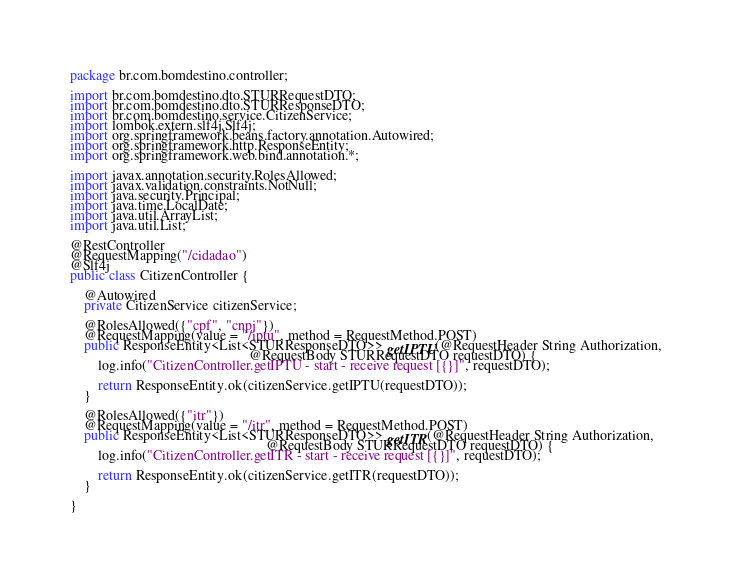Convert code to text. <code><loc_0><loc_0><loc_500><loc_500><_Java_>package br.com.bomdestino.controller;

import br.com.bomdestino.dto.STURRequestDTO;
import br.com.bomdestino.dto.STURResponseDTO;
import br.com.bomdestino.service.CitizenService;
import lombok.extern.slf4j.Slf4j;
import org.springframework.beans.factory.annotation.Autowired;
import org.springframework.http.ResponseEntity;
import org.springframework.web.bind.annotation.*;

import javax.annotation.security.RolesAllowed;
import javax.validation.constraints.NotNull;
import java.security.Principal;
import java.time.LocalDate;
import java.util.ArrayList;
import java.util.List;

@RestController
@RequestMapping("/cidadao")
@Slf4j
public class CitizenController {

    @Autowired
    private CitizenService citizenService;

    @RolesAllowed({"cpf", "cnpj"})
    @RequestMapping(value = "/iptu", method = RequestMethod.POST)
    public ResponseEntity<List<STURResponseDTO>> getIPTU(@RequestHeader String Authorization,
                                                   @RequestBody STURRequestDTO requestDTO) {
        log.info("CitizenController.getIPTU - start - receive request [{}]", requestDTO);

        return ResponseEntity.ok(citizenService.getIPTU(requestDTO));
    }

    @RolesAllowed({"itr"})
    @RequestMapping(value = "/itr", method = RequestMethod.POST)
    public ResponseEntity<List<STURResponseDTO>> getITR(@RequestHeader String Authorization,
                                                        @RequestBody STURRequestDTO requestDTO) {
        log.info("CitizenController.getITR - start - receive request [{}]", requestDTO);

        return ResponseEntity.ok(citizenService.getITR(requestDTO));
    }

}</code> 